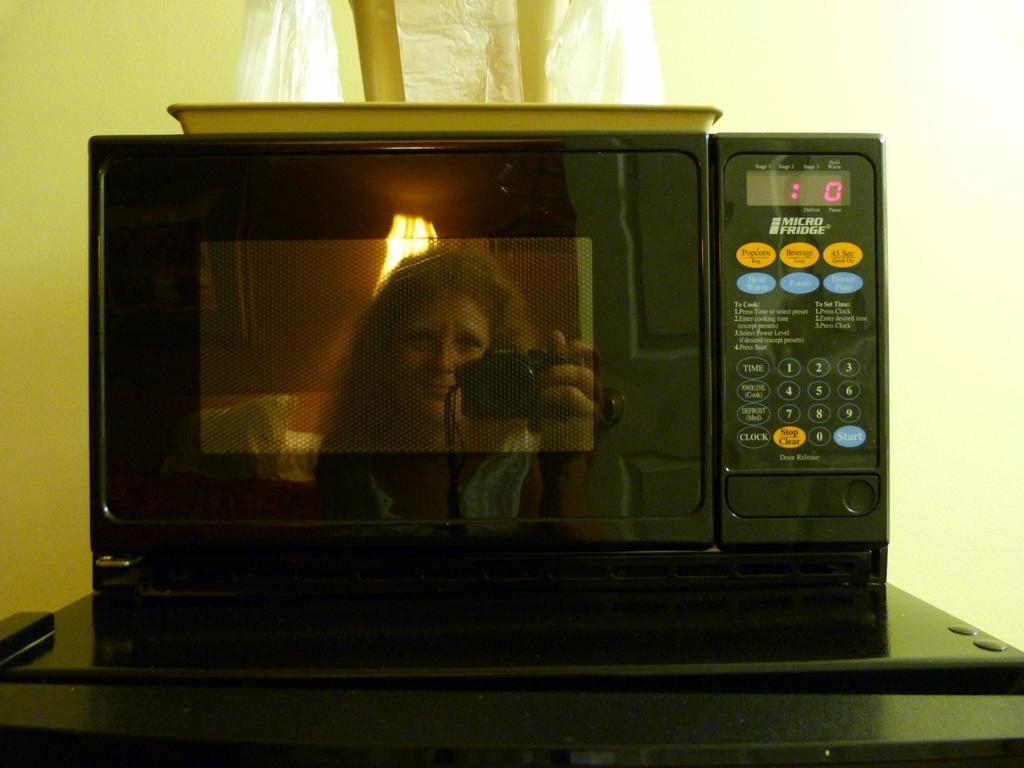Provide a one-sentence caption for the provided image. A black microwave oven with no time left on the timer. 